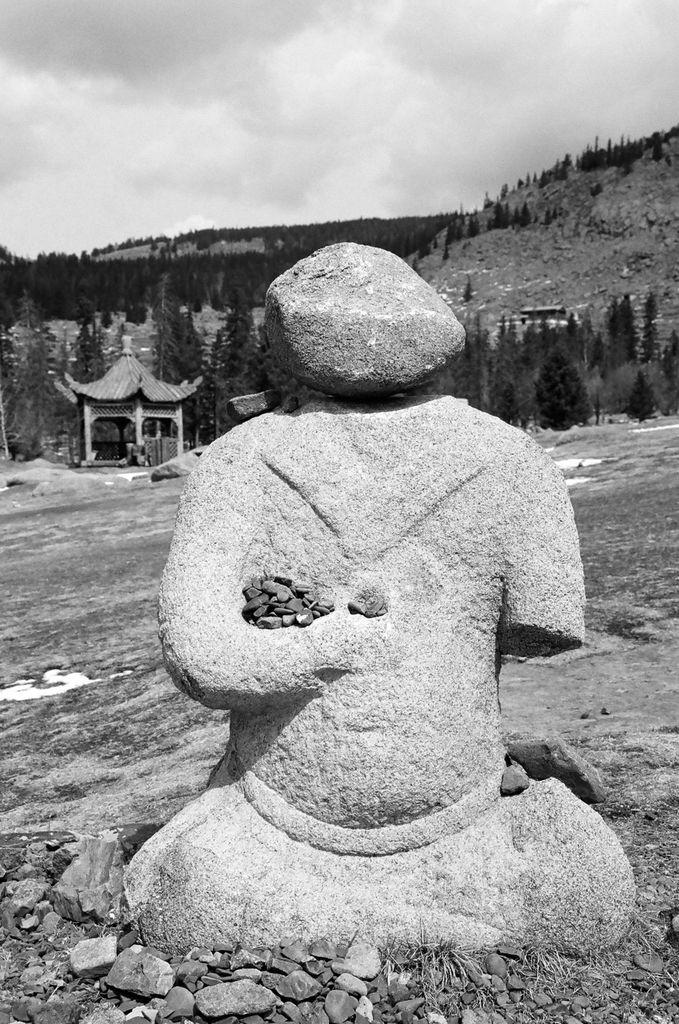What is the main subject of the image? There is a sculpture in the image. What can be seen in the background of the image? There are trees, the sky, and a shed in the background of the image. What is the color scheme of the image? The image is black and white in color. What type of dress is the person wearing in the image? There is no person present in the image, only a sculpture. Can you tell me what the argument is about in the image? There is no argument depicted in the image; it features a sculpture and background elements. 